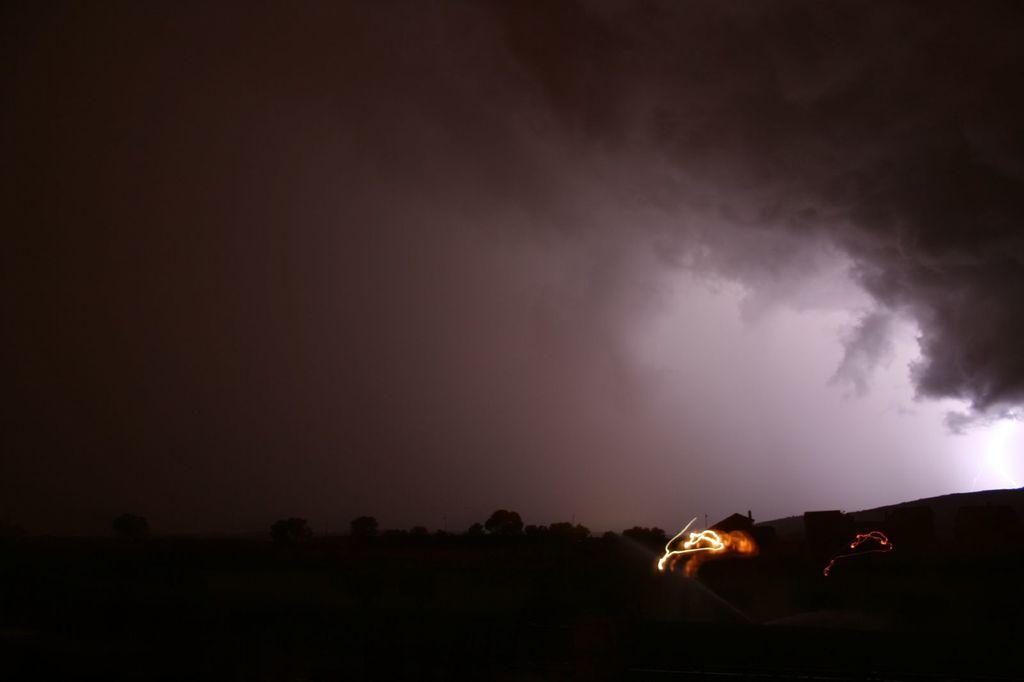How would you summarize this image in a sentence or two? In this image we can see trees, houses, sky and clouds. 